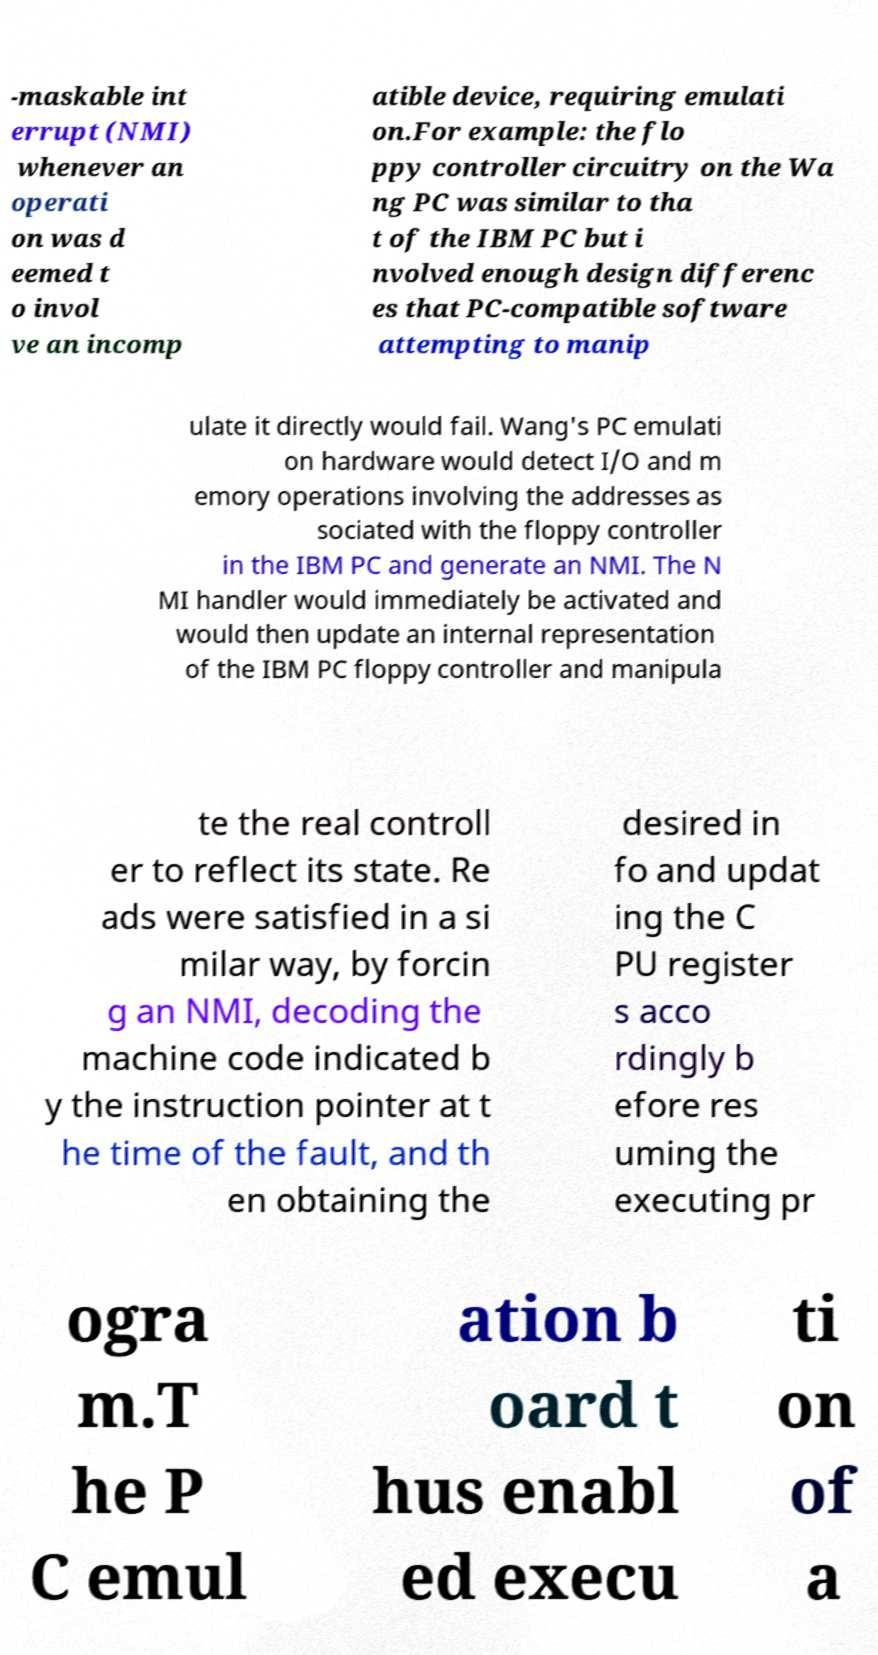Please identify and transcribe the text found in this image. -maskable int errupt (NMI) whenever an operati on was d eemed t o invol ve an incomp atible device, requiring emulati on.For example: the flo ppy controller circuitry on the Wa ng PC was similar to tha t of the IBM PC but i nvolved enough design differenc es that PC-compatible software attempting to manip ulate it directly would fail. Wang's PC emulati on hardware would detect I/O and m emory operations involving the addresses as sociated with the floppy controller in the IBM PC and generate an NMI. The N MI handler would immediately be activated and would then update an internal representation of the IBM PC floppy controller and manipula te the real controll er to reflect its state. Re ads were satisfied in a si milar way, by forcin g an NMI, decoding the machine code indicated b y the instruction pointer at t he time of the fault, and th en obtaining the desired in fo and updat ing the C PU register s acco rdingly b efore res uming the executing pr ogra m.T he P C emul ation b oard t hus enabl ed execu ti on of a 